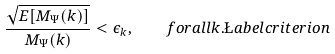<formula> <loc_0><loc_0><loc_500><loc_500>\frac { \sqrt { E [ M _ { \Psi } ( k ) ] } } { M _ { \Psi } ( k ) } < \epsilon _ { k } , \quad f o r a l l k . \L a b e l { c r i t e r i o n }</formula> 